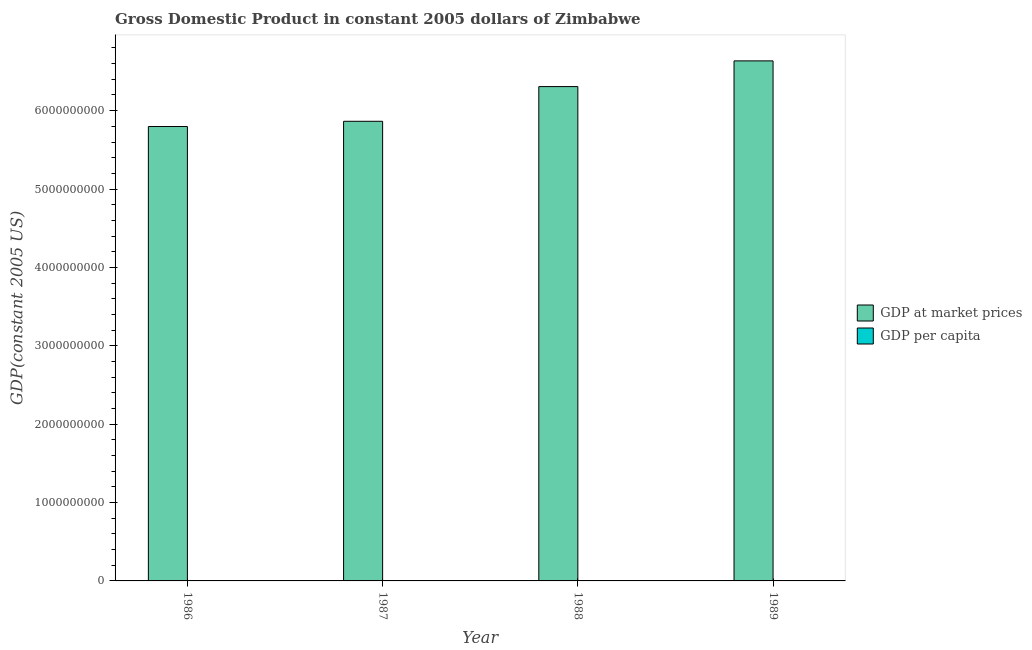How many groups of bars are there?
Provide a succinct answer. 4. Are the number of bars per tick equal to the number of legend labels?
Your answer should be very brief. Yes. Are the number of bars on each tick of the X-axis equal?
Provide a short and direct response. Yes. How many bars are there on the 3rd tick from the left?
Provide a short and direct response. 2. How many bars are there on the 1st tick from the right?
Make the answer very short. 2. What is the label of the 1st group of bars from the left?
Provide a short and direct response. 1986. What is the gdp per capita in 1989?
Provide a short and direct response. 651.47. Across all years, what is the maximum gdp per capita?
Make the answer very short. 651.47. Across all years, what is the minimum gdp per capita?
Offer a very short reply. 614.99. In which year was the gdp at market prices maximum?
Ensure brevity in your answer.  1989. In which year was the gdp per capita minimum?
Offer a very short reply. 1987. What is the total gdp at market prices in the graph?
Your answer should be compact. 2.46e+1. What is the difference between the gdp at market prices in 1987 and that in 1989?
Your answer should be very brief. -7.71e+08. What is the difference between the gdp at market prices in 1986 and the gdp per capita in 1987?
Your answer should be compact. -6.67e+07. What is the average gdp per capita per year?
Make the answer very short. 633.99. In the year 1988, what is the difference between the gdp at market prices and gdp per capita?
Your answer should be very brief. 0. What is the ratio of the gdp per capita in 1987 to that in 1988?
Ensure brevity in your answer.  0.96. Is the gdp per capita in 1986 less than that in 1987?
Make the answer very short. No. Is the difference between the gdp at market prices in 1986 and 1988 greater than the difference between the gdp per capita in 1986 and 1988?
Give a very brief answer. No. What is the difference between the highest and the second highest gdp at market prices?
Give a very brief answer. 3.28e+08. What is the difference between the highest and the lowest gdp at market prices?
Your response must be concise. 8.38e+08. In how many years, is the gdp at market prices greater than the average gdp at market prices taken over all years?
Provide a succinct answer. 2. What does the 2nd bar from the left in 1989 represents?
Give a very brief answer. GDP per capita. What does the 1st bar from the right in 1987 represents?
Keep it short and to the point. GDP per capita. Are all the bars in the graph horizontal?
Keep it short and to the point. No. Does the graph contain any zero values?
Offer a very short reply. No. Does the graph contain grids?
Make the answer very short. No. Where does the legend appear in the graph?
Make the answer very short. Center right. What is the title of the graph?
Provide a short and direct response. Gross Domestic Product in constant 2005 dollars of Zimbabwe. What is the label or title of the X-axis?
Provide a succinct answer. Year. What is the label or title of the Y-axis?
Your answer should be compact. GDP(constant 2005 US). What is the GDP(constant 2005 US) in GDP at market prices in 1986?
Provide a succinct answer. 5.80e+09. What is the GDP(constant 2005 US) of GDP per capita in 1986?
Offer a very short reply. 630.25. What is the GDP(constant 2005 US) of GDP at market prices in 1987?
Provide a succinct answer. 5.86e+09. What is the GDP(constant 2005 US) of GDP per capita in 1987?
Ensure brevity in your answer.  614.99. What is the GDP(constant 2005 US) of GDP at market prices in 1988?
Your response must be concise. 6.31e+09. What is the GDP(constant 2005 US) in GDP per capita in 1988?
Make the answer very short. 639.24. What is the GDP(constant 2005 US) in GDP at market prices in 1989?
Give a very brief answer. 6.64e+09. What is the GDP(constant 2005 US) of GDP per capita in 1989?
Offer a terse response. 651.47. Across all years, what is the maximum GDP(constant 2005 US) of GDP at market prices?
Provide a short and direct response. 6.64e+09. Across all years, what is the maximum GDP(constant 2005 US) of GDP per capita?
Make the answer very short. 651.47. Across all years, what is the minimum GDP(constant 2005 US) of GDP at market prices?
Offer a terse response. 5.80e+09. Across all years, what is the minimum GDP(constant 2005 US) in GDP per capita?
Make the answer very short. 614.99. What is the total GDP(constant 2005 US) in GDP at market prices in the graph?
Give a very brief answer. 2.46e+1. What is the total GDP(constant 2005 US) in GDP per capita in the graph?
Keep it short and to the point. 2535.94. What is the difference between the GDP(constant 2005 US) of GDP at market prices in 1986 and that in 1987?
Provide a short and direct response. -6.67e+07. What is the difference between the GDP(constant 2005 US) of GDP per capita in 1986 and that in 1987?
Offer a very short reply. 15.26. What is the difference between the GDP(constant 2005 US) of GDP at market prices in 1986 and that in 1988?
Ensure brevity in your answer.  -5.10e+08. What is the difference between the GDP(constant 2005 US) in GDP per capita in 1986 and that in 1988?
Your response must be concise. -8.99. What is the difference between the GDP(constant 2005 US) of GDP at market prices in 1986 and that in 1989?
Make the answer very short. -8.38e+08. What is the difference between the GDP(constant 2005 US) of GDP per capita in 1986 and that in 1989?
Offer a terse response. -21.22. What is the difference between the GDP(constant 2005 US) in GDP at market prices in 1987 and that in 1988?
Your response must be concise. -4.43e+08. What is the difference between the GDP(constant 2005 US) of GDP per capita in 1987 and that in 1988?
Keep it short and to the point. -24.25. What is the difference between the GDP(constant 2005 US) of GDP at market prices in 1987 and that in 1989?
Offer a very short reply. -7.71e+08. What is the difference between the GDP(constant 2005 US) of GDP per capita in 1987 and that in 1989?
Give a very brief answer. -36.48. What is the difference between the GDP(constant 2005 US) in GDP at market prices in 1988 and that in 1989?
Ensure brevity in your answer.  -3.28e+08. What is the difference between the GDP(constant 2005 US) of GDP per capita in 1988 and that in 1989?
Your answer should be compact. -12.23. What is the difference between the GDP(constant 2005 US) in GDP at market prices in 1986 and the GDP(constant 2005 US) in GDP per capita in 1987?
Your answer should be compact. 5.80e+09. What is the difference between the GDP(constant 2005 US) of GDP at market prices in 1986 and the GDP(constant 2005 US) of GDP per capita in 1988?
Offer a terse response. 5.80e+09. What is the difference between the GDP(constant 2005 US) in GDP at market prices in 1986 and the GDP(constant 2005 US) in GDP per capita in 1989?
Provide a short and direct response. 5.80e+09. What is the difference between the GDP(constant 2005 US) in GDP at market prices in 1987 and the GDP(constant 2005 US) in GDP per capita in 1988?
Ensure brevity in your answer.  5.86e+09. What is the difference between the GDP(constant 2005 US) of GDP at market prices in 1987 and the GDP(constant 2005 US) of GDP per capita in 1989?
Give a very brief answer. 5.86e+09. What is the difference between the GDP(constant 2005 US) in GDP at market prices in 1988 and the GDP(constant 2005 US) in GDP per capita in 1989?
Your answer should be very brief. 6.31e+09. What is the average GDP(constant 2005 US) of GDP at market prices per year?
Provide a succinct answer. 6.15e+09. What is the average GDP(constant 2005 US) in GDP per capita per year?
Your answer should be very brief. 633.99. In the year 1986, what is the difference between the GDP(constant 2005 US) of GDP at market prices and GDP(constant 2005 US) of GDP per capita?
Ensure brevity in your answer.  5.80e+09. In the year 1987, what is the difference between the GDP(constant 2005 US) in GDP at market prices and GDP(constant 2005 US) in GDP per capita?
Your response must be concise. 5.86e+09. In the year 1988, what is the difference between the GDP(constant 2005 US) in GDP at market prices and GDP(constant 2005 US) in GDP per capita?
Provide a short and direct response. 6.31e+09. In the year 1989, what is the difference between the GDP(constant 2005 US) in GDP at market prices and GDP(constant 2005 US) in GDP per capita?
Offer a very short reply. 6.64e+09. What is the ratio of the GDP(constant 2005 US) in GDP per capita in 1986 to that in 1987?
Give a very brief answer. 1.02. What is the ratio of the GDP(constant 2005 US) in GDP at market prices in 1986 to that in 1988?
Make the answer very short. 0.92. What is the ratio of the GDP(constant 2005 US) of GDP per capita in 1986 to that in 1988?
Offer a very short reply. 0.99. What is the ratio of the GDP(constant 2005 US) in GDP at market prices in 1986 to that in 1989?
Offer a terse response. 0.87. What is the ratio of the GDP(constant 2005 US) in GDP per capita in 1986 to that in 1989?
Offer a terse response. 0.97. What is the ratio of the GDP(constant 2005 US) of GDP at market prices in 1987 to that in 1988?
Offer a very short reply. 0.93. What is the ratio of the GDP(constant 2005 US) of GDP per capita in 1987 to that in 1988?
Make the answer very short. 0.96. What is the ratio of the GDP(constant 2005 US) of GDP at market prices in 1987 to that in 1989?
Make the answer very short. 0.88. What is the ratio of the GDP(constant 2005 US) of GDP per capita in 1987 to that in 1989?
Make the answer very short. 0.94. What is the ratio of the GDP(constant 2005 US) in GDP at market prices in 1988 to that in 1989?
Give a very brief answer. 0.95. What is the ratio of the GDP(constant 2005 US) of GDP per capita in 1988 to that in 1989?
Provide a short and direct response. 0.98. What is the difference between the highest and the second highest GDP(constant 2005 US) of GDP at market prices?
Offer a very short reply. 3.28e+08. What is the difference between the highest and the second highest GDP(constant 2005 US) of GDP per capita?
Keep it short and to the point. 12.23. What is the difference between the highest and the lowest GDP(constant 2005 US) in GDP at market prices?
Keep it short and to the point. 8.38e+08. What is the difference between the highest and the lowest GDP(constant 2005 US) in GDP per capita?
Keep it short and to the point. 36.48. 